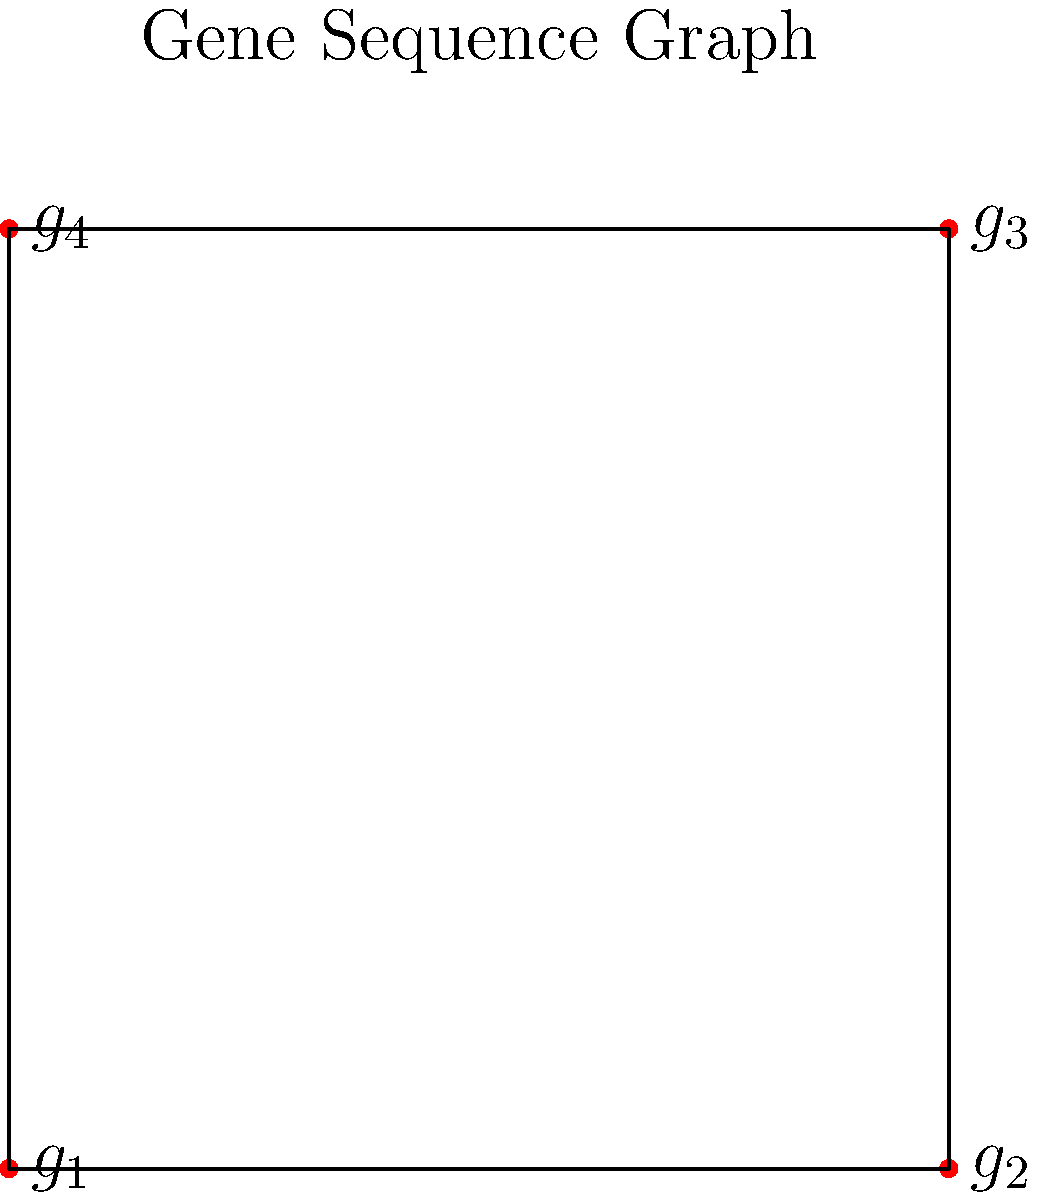Consider a permutation group acting on a gene sequence of a food crop represented by the graph above. If the permutation $(g_1 \; g_2 \; g_3 \; g_4)$ represents a cyclic shift in the gene sequence, how many distinct permutations can be generated by repeatedly applying this permutation, and what is the order of the resulting cyclic subgroup? To solve this problem, let's follow these steps:

1) The permutation $(g_1 \; g_2 \; g_3 \; g_4)$ represents a cyclic shift of the gene sequence, moving each gene to the next position (with $g_4$ moving to $g_1$'s position).

2) Let's apply this permutation repeatedly:
   - Original: $(g_1, g_2, g_3, g_4)$
   - After 1 application: $(g_4, g_1, g_2, g_3)$
   - After 2 applications: $(g_3, g_4, g_1, g_2)$
   - After 3 applications: $(g_2, g_3, g_4, g_1)$
   - After 4 applications: $(g_1, g_2, g_3, g_4)$ (back to the original)

3) We see that after 4 applications, we return to the original sequence. This means that the permutation generates a cyclic subgroup of order 4.

4) The distinct permutations generated are:
   $(g_1 \; g_2 \; g_3 \; g_4)$, $(g_4 \; g_1 \; g_2 \; g_3)$, $(g_3 \; g_4 \; g_1 \; g_2)$, $(g_2 \; g_3 \; g_4 \; g_1)$

5) The number of distinct permutations is equal to the order of the cyclic subgroup, which is 4.

Therefore, the permutation generates 4 distinct permutations, and the order of the resulting cyclic subgroup is 4.
Answer: 4 distinct permutations; order 4 